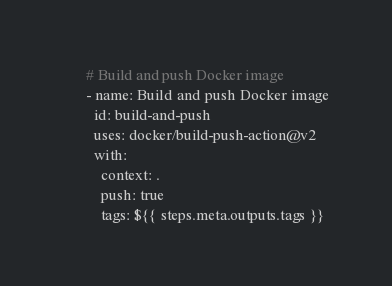<code> <loc_0><loc_0><loc_500><loc_500><_YAML_>
      # Build and push Docker image
      - name: Build and push Docker image
        id: build-and-push
        uses: docker/build-push-action@v2
        with:
          context: .
          push: true
          tags: ${{ steps.meta.outputs.tags }}
</code> 